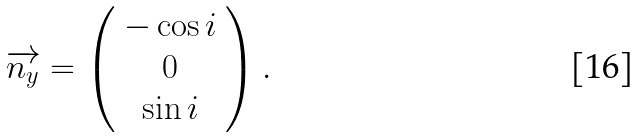Convert formula to latex. <formula><loc_0><loc_0><loc_500><loc_500>\overrightarrow { n _ { y } } = \left ( \begin{array} { c } - \cos i \\ 0 \\ \sin i \end{array} \right ) .</formula> 